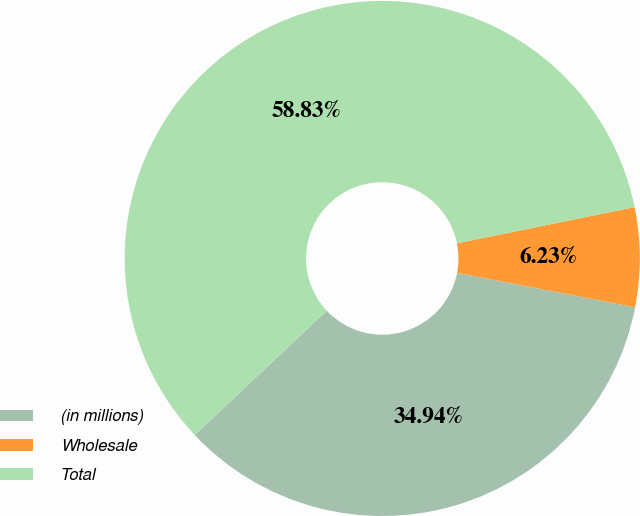<chart> <loc_0><loc_0><loc_500><loc_500><pie_chart><fcel>(in millions)<fcel>Wholesale<fcel>Total<nl><fcel>34.94%<fcel>6.23%<fcel>58.82%<nl></chart> 